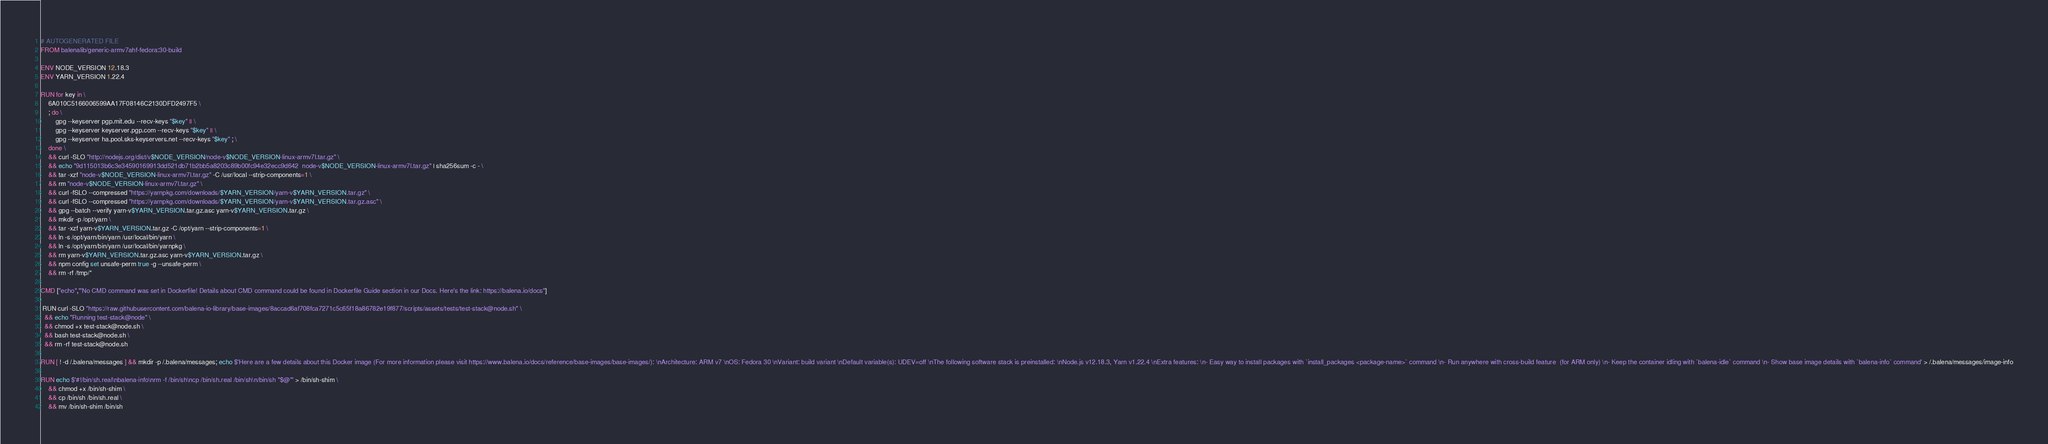Convert code to text. <code><loc_0><loc_0><loc_500><loc_500><_Dockerfile_># AUTOGENERATED FILE
FROM balenalib/generic-armv7ahf-fedora:30-build

ENV NODE_VERSION 12.18.3
ENV YARN_VERSION 1.22.4

RUN for key in \
	6A010C5166006599AA17F08146C2130DFD2497F5 \
	; do \
		gpg --keyserver pgp.mit.edu --recv-keys "$key" || \
		gpg --keyserver keyserver.pgp.com --recv-keys "$key" || \
		gpg --keyserver ha.pool.sks-keyservers.net --recv-keys "$key" ; \
	done \
	&& curl -SLO "http://nodejs.org/dist/v$NODE_VERSION/node-v$NODE_VERSION-linux-armv7l.tar.gz" \
	&& echo "9d115013b6c3e34590169913dd521db71b2bb5a8203c89b00fc94e32ecc9d642  node-v$NODE_VERSION-linux-armv7l.tar.gz" | sha256sum -c - \
	&& tar -xzf "node-v$NODE_VERSION-linux-armv7l.tar.gz" -C /usr/local --strip-components=1 \
	&& rm "node-v$NODE_VERSION-linux-armv7l.tar.gz" \
	&& curl -fSLO --compressed "https://yarnpkg.com/downloads/$YARN_VERSION/yarn-v$YARN_VERSION.tar.gz" \
	&& curl -fSLO --compressed "https://yarnpkg.com/downloads/$YARN_VERSION/yarn-v$YARN_VERSION.tar.gz.asc" \
	&& gpg --batch --verify yarn-v$YARN_VERSION.tar.gz.asc yarn-v$YARN_VERSION.tar.gz \
	&& mkdir -p /opt/yarn \
	&& tar -xzf yarn-v$YARN_VERSION.tar.gz -C /opt/yarn --strip-components=1 \
	&& ln -s /opt/yarn/bin/yarn /usr/local/bin/yarn \
	&& ln -s /opt/yarn/bin/yarn /usr/local/bin/yarnpkg \
	&& rm yarn-v$YARN_VERSION.tar.gz.asc yarn-v$YARN_VERSION.tar.gz \
	&& npm config set unsafe-perm true -g --unsafe-perm \
	&& rm -rf /tmp/*

CMD ["echo","'No CMD command was set in Dockerfile! Details about CMD command could be found in Dockerfile Guide section in our Docs. Here's the link: https://balena.io/docs"]

 RUN curl -SLO "https://raw.githubusercontent.com/balena-io-library/base-images/8accad6af708fca7271c5c65f18a86782e19f877/scripts/assets/tests/test-stack@node.sh" \
  && echo "Running test-stack@node" \
  && chmod +x test-stack@node.sh \
  && bash test-stack@node.sh \
  && rm -rf test-stack@node.sh 

RUN [ ! -d /.balena/messages ] && mkdir -p /.balena/messages; echo $'Here are a few details about this Docker image (For more information please visit https://www.balena.io/docs/reference/base-images/base-images/): \nArchitecture: ARM v7 \nOS: Fedora 30 \nVariant: build variant \nDefault variable(s): UDEV=off \nThe following software stack is preinstalled: \nNode.js v12.18.3, Yarn v1.22.4 \nExtra features: \n- Easy way to install packages with `install_packages <package-name>` command \n- Run anywhere with cross-build feature  (for ARM only) \n- Keep the container idling with `balena-idle` command \n- Show base image details with `balena-info` command' > /.balena/messages/image-info

RUN echo $'#!/bin/sh.real\nbalena-info\nrm -f /bin/sh\ncp /bin/sh.real /bin/sh\n/bin/sh "$@"' > /bin/sh-shim \
	&& chmod +x /bin/sh-shim \
	&& cp /bin/sh /bin/sh.real \
	&& mv /bin/sh-shim /bin/sh</code> 